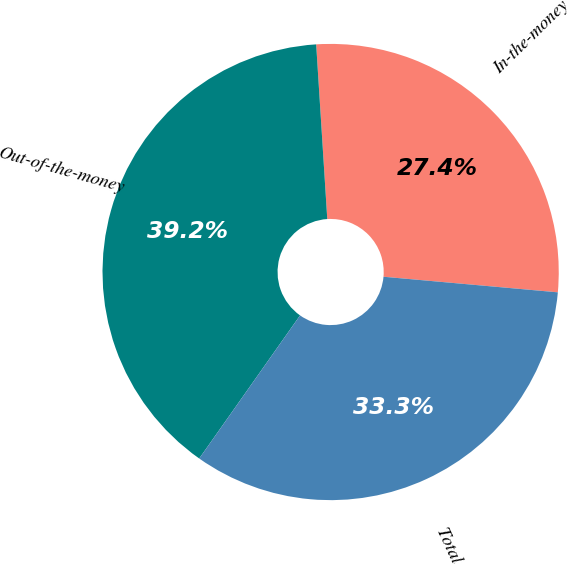Convert chart to OTSL. <chart><loc_0><loc_0><loc_500><loc_500><pie_chart><fcel>In-the-money<fcel>Out-of-the-money<fcel>Total<nl><fcel>27.43%<fcel>39.22%<fcel>33.35%<nl></chart> 